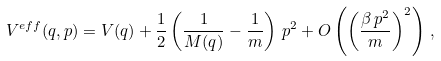Convert formula to latex. <formula><loc_0><loc_0><loc_500><loc_500>V ^ { e f f } ( q , p ) = V ( q ) + \frac { 1 } { 2 } \left ( \frac { 1 } { M ( q ) } - \frac { 1 } { m } \right ) \, p ^ { 2 } + O \left ( \left ( \frac { \beta \, p ^ { 2 } } { m } \right ) ^ { 2 } \right ) \, ,</formula> 